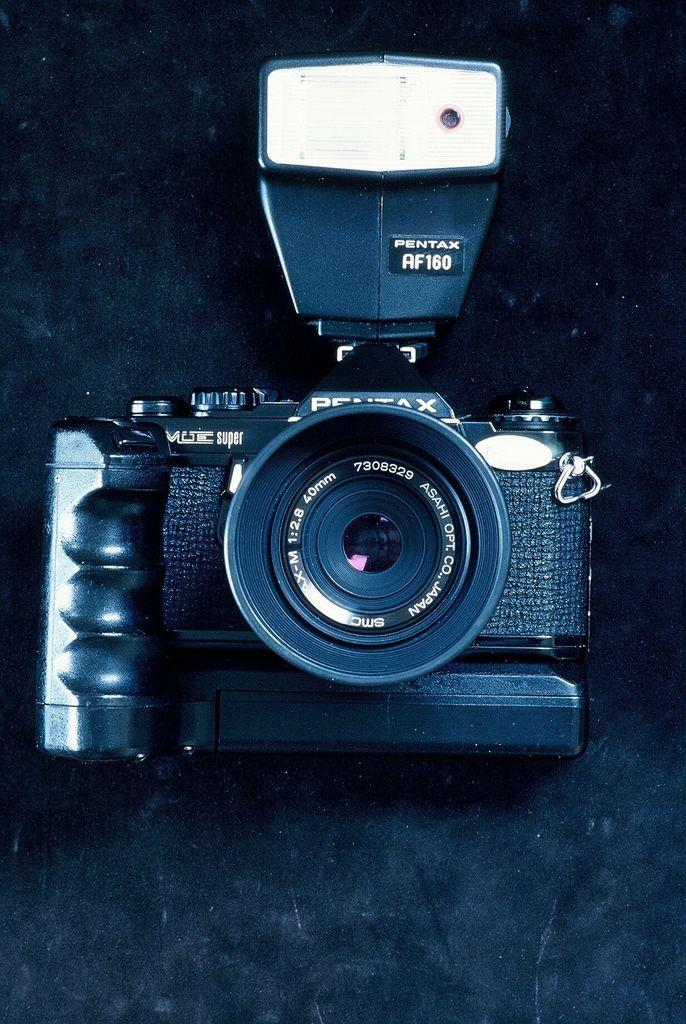What is the main subject in the center of the image? There is a camera in the center of the image. What type of songs can be heard coming from the quill in the image? There is no quill or songs present in the image; it features a camera in the center. 